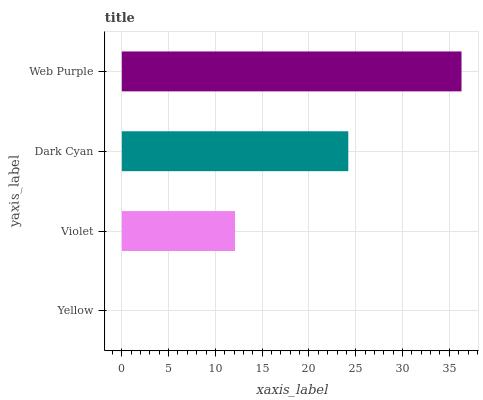Is Yellow the minimum?
Answer yes or no. Yes. Is Web Purple the maximum?
Answer yes or no. Yes. Is Violet the minimum?
Answer yes or no. No. Is Violet the maximum?
Answer yes or no. No. Is Violet greater than Yellow?
Answer yes or no. Yes. Is Yellow less than Violet?
Answer yes or no. Yes. Is Yellow greater than Violet?
Answer yes or no. No. Is Violet less than Yellow?
Answer yes or no. No. Is Dark Cyan the high median?
Answer yes or no. Yes. Is Violet the low median?
Answer yes or no. Yes. Is Web Purple the high median?
Answer yes or no. No. Is Dark Cyan the low median?
Answer yes or no. No. 